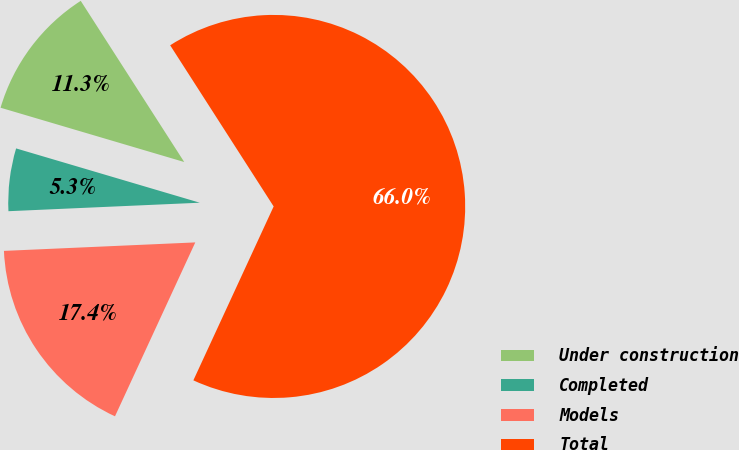<chart> <loc_0><loc_0><loc_500><loc_500><pie_chart><fcel>Under construction<fcel>Completed<fcel>Models<fcel>Total<nl><fcel>11.34%<fcel>5.28%<fcel>17.41%<fcel>65.97%<nl></chart> 